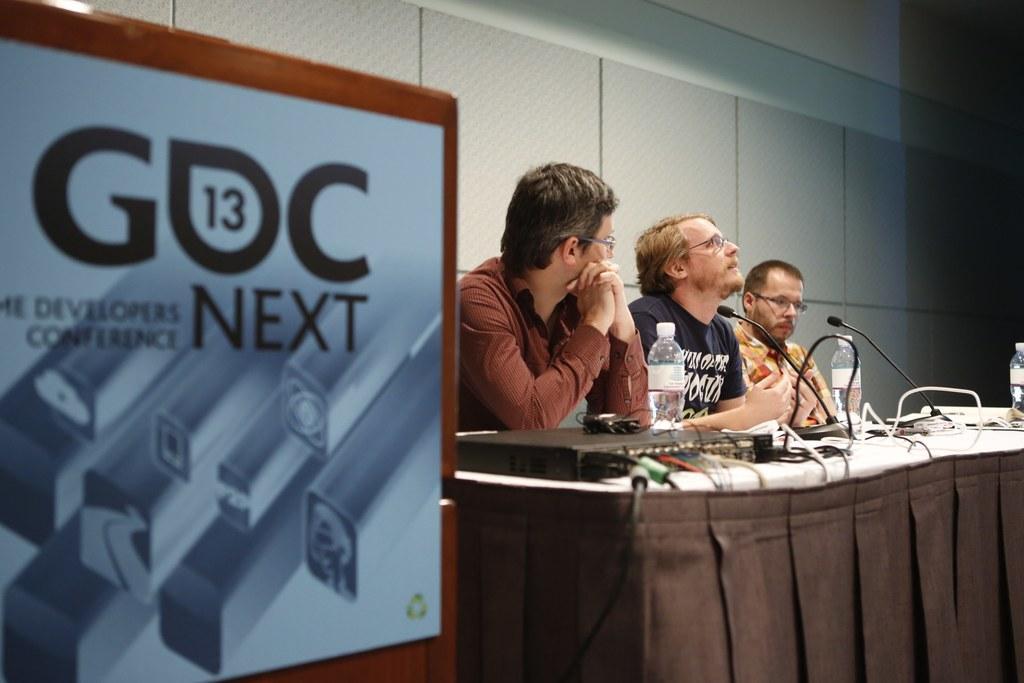In one or two sentences, can you explain what this image depicts? As we can see in the image there are tiles, banner, few people siting on chairs and a table. On table there is a projector, bottles, papers and mics. 